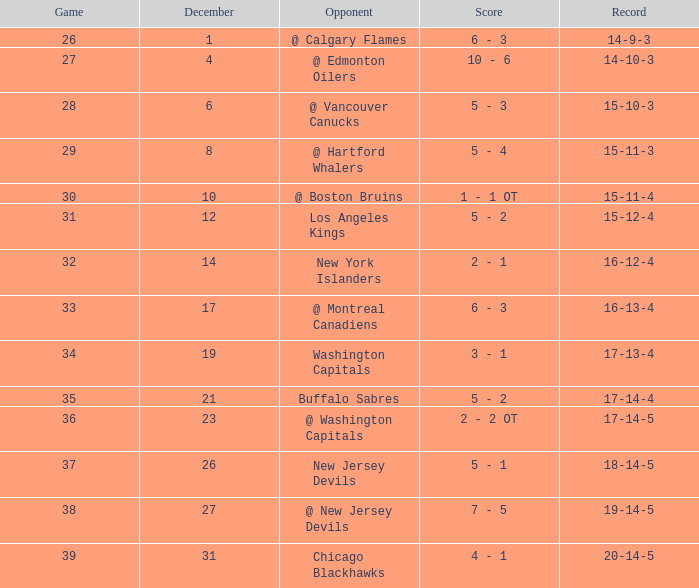Record of 15-12-4, and a Game larger than 31 involves what highest December? None. 